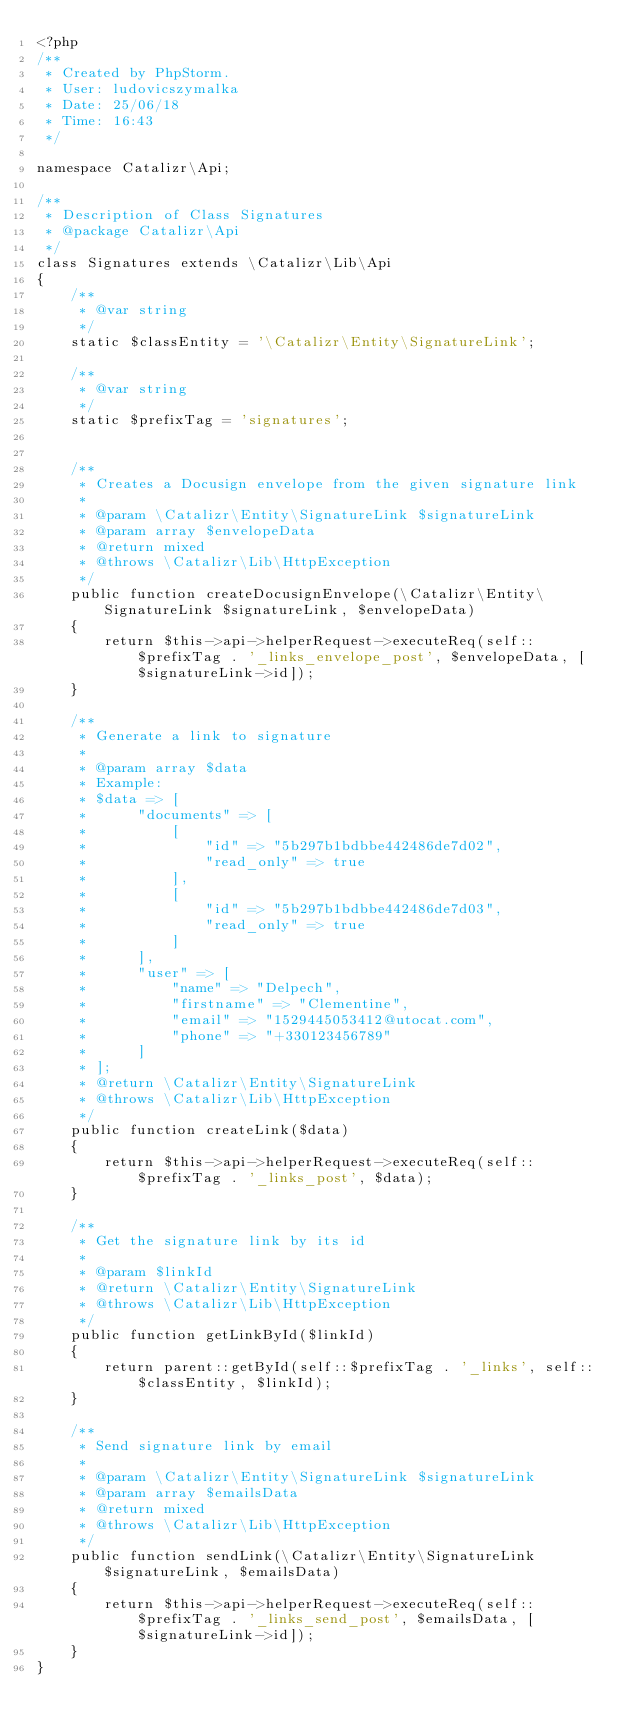<code> <loc_0><loc_0><loc_500><loc_500><_PHP_><?php
/**
 * Created by PhpStorm.
 * User: ludovicszymalka
 * Date: 25/06/18
 * Time: 16:43
 */

namespace Catalizr\Api;

/**
 * Description of Class Signatures
 * @package Catalizr\Api
 */
class Signatures extends \Catalizr\Lib\Api
{
    /**
     * @var string
     */
    static $classEntity = '\Catalizr\Entity\SignatureLink';

    /**
     * @var string
     */
    static $prefixTag = 'signatures';


    /**
     * Creates a Docusign envelope from the given signature link
     *
     * @param \Catalizr\Entity\SignatureLink $signatureLink
     * @param array $envelopeData
     * @return mixed
     * @throws \Catalizr\Lib\HttpException
     */
    public function createDocusignEnvelope(\Catalizr\Entity\SignatureLink $signatureLink, $envelopeData)
    {
        return $this->api->helperRequest->executeReq(self::$prefixTag . '_links_envelope_post', $envelopeData, [$signatureLink->id]);
    }

    /**
     * Generate a link to signature
     *
     * @param array $data
     * Example:
     * $data => [
     *      "documents" => [
     *          [
     *              "id" => "5b297b1bdbbe442486de7d02",
     *              "read_only" => true
     *          ],
     *          [
     *              "id" => "5b297b1bdbbe442486de7d03",
     *              "read_only" => true
     *          ]
     *      ],
     *      "user" => [
     *          "name" => "Delpech",
     *          "firstname" => "Clementine",
     *          "email" => "1529445053412@utocat.com",
     *          "phone" => "+330123456789"
     *      ]
     * ];
     * @return \Catalizr\Entity\SignatureLink
     * @throws \Catalizr\Lib\HttpException
     */
    public function createLink($data)
    {
        return $this->api->helperRequest->executeReq(self::$prefixTag . '_links_post', $data);
    }

    /**
     * Get the signature link by its id
     *
     * @param $linkId
     * @return \Catalizr\Entity\SignatureLink
     * @throws \Catalizr\Lib\HttpException
     */
    public function getLinkById($linkId)
    {
        return parent::getById(self::$prefixTag . '_links', self::$classEntity, $linkId);
    }

    /**
     * Send signature link by email
     *
     * @param \Catalizr\Entity\SignatureLink $signatureLink
     * @param array $emailsData
     * @return mixed
     * @throws \Catalizr\Lib\HttpException
     */
    public function sendLink(\Catalizr\Entity\SignatureLink $signatureLink, $emailsData)
    {
        return $this->api->helperRequest->executeReq(self::$prefixTag . '_links_send_post', $emailsData, [$signatureLink->id]);
    }
}
</code> 